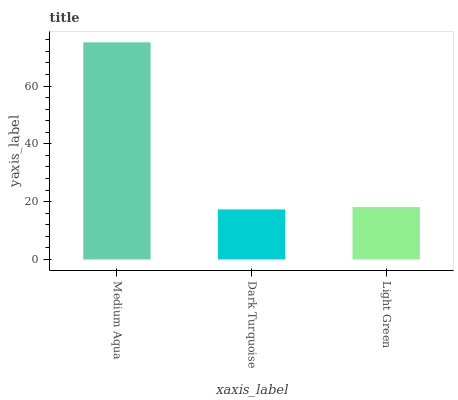Is Dark Turquoise the minimum?
Answer yes or no. Yes. Is Medium Aqua the maximum?
Answer yes or no. Yes. Is Light Green the minimum?
Answer yes or no. No. Is Light Green the maximum?
Answer yes or no. No. Is Light Green greater than Dark Turquoise?
Answer yes or no. Yes. Is Dark Turquoise less than Light Green?
Answer yes or no. Yes. Is Dark Turquoise greater than Light Green?
Answer yes or no. No. Is Light Green less than Dark Turquoise?
Answer yes or no. No. Is Light Green the high median?
Answer yes or no. Yes. Is Light Green the low median?
Answer yes or no. Yes. Is Dark Turquoise the high median?
Answer yes or no. No. Is Medium Aqua the low median?
Answer yes or no. No. 